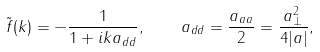Convert formula to latex. <formula><loc_0><loc_0><loc_500><loc_500>\tilde { f } ( k ) = - \frac { 1 } { 1 + i k a _ { d d } } , \quad a _ { d d } = \frac { a _ { a a } } { 2 } = \frac { a _ { \perp } ^ { 2 } } { 4 | a | } ,</formula> 